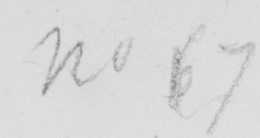What is written in this line of handwriting? No 6 7 